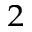<formula> <loc_0><loc_0><loc_500><loc_500>^ { 2 }</formula> 